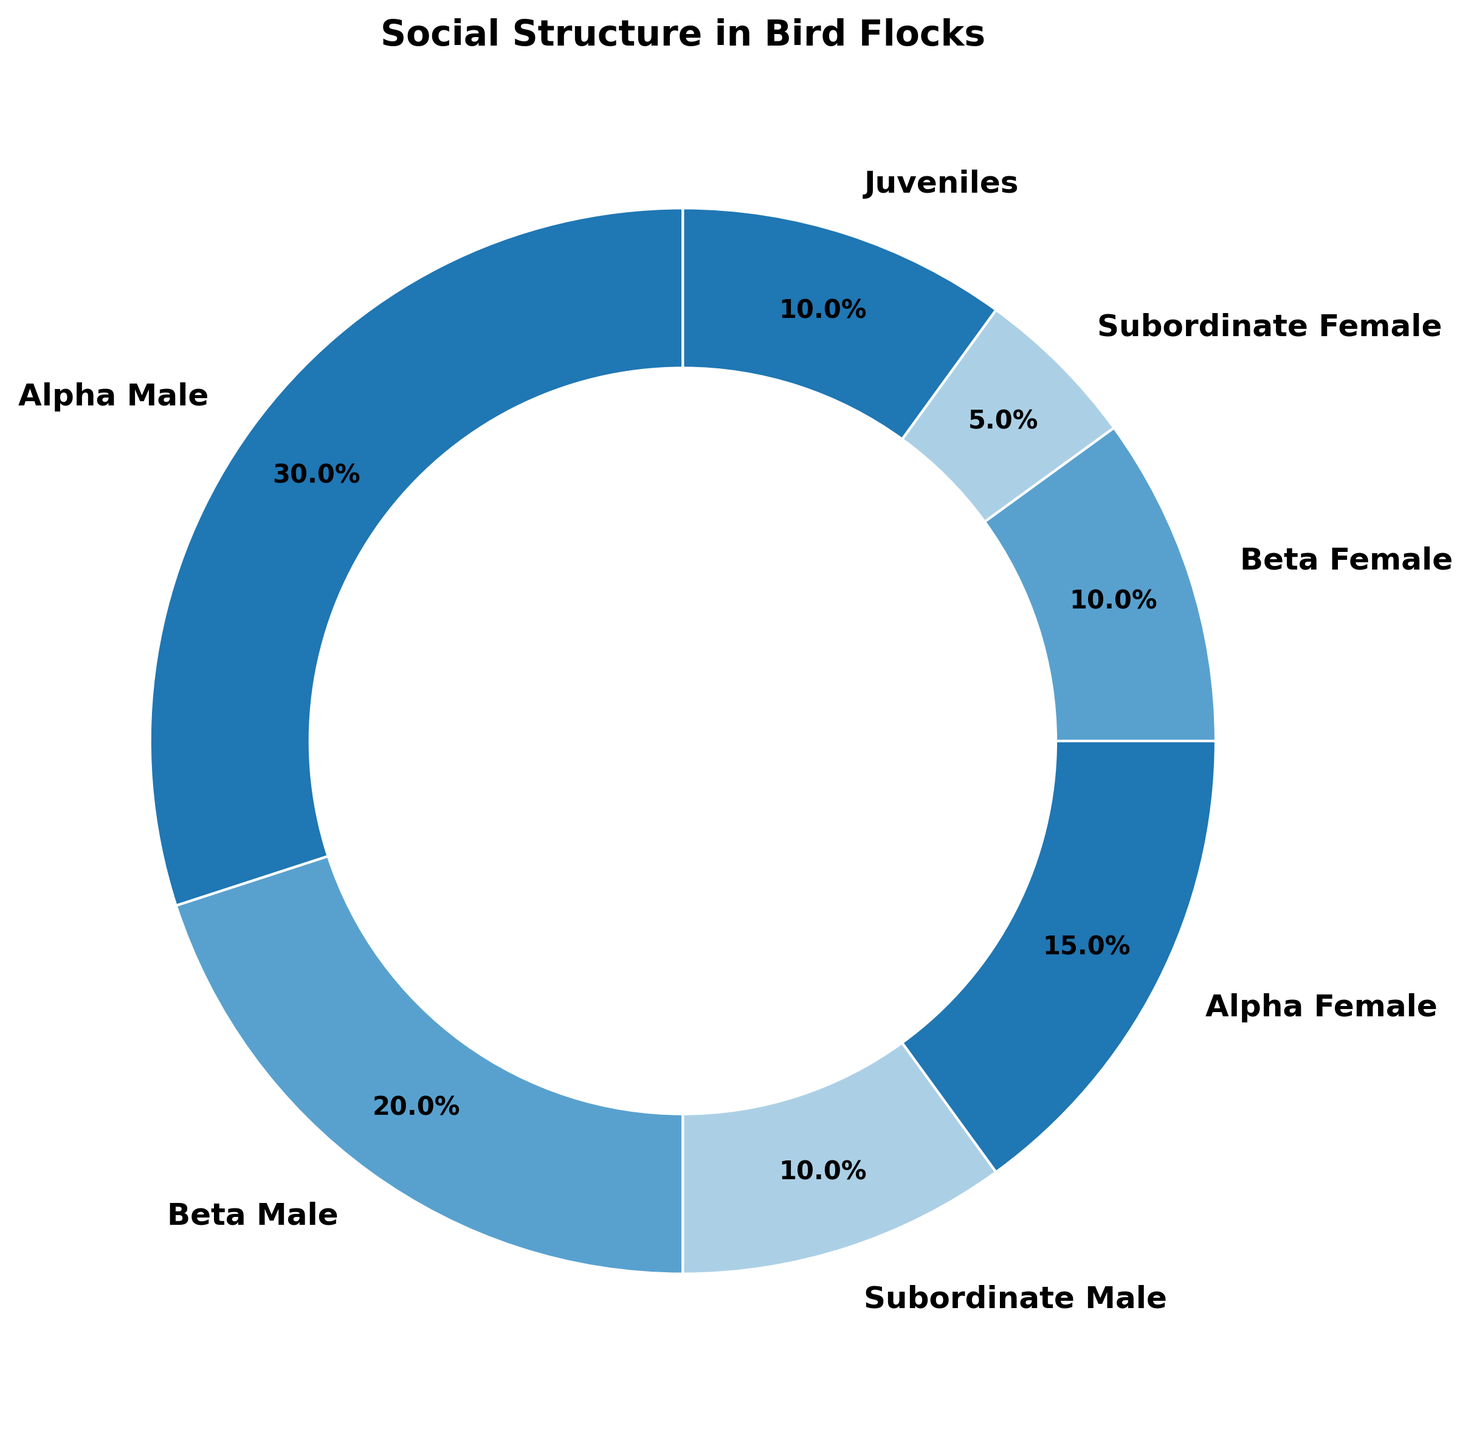What role has the highest percentage in the bird flocks? Alpha Male is at the top with the largest slice in the ring chart, showing a percentage of 30%.
Answer: Alpha Male Which two roles have the smallest percentages in the bird flocks? By looking at the slices, Subordinate Female has 5%, and two other sections, Subordinate Male and Juveniles, each have 10%. Therefore, Subordinate Female and one of these two roles have the smallest percentages, but the absolute smallest are Subordinate Female and tie between Subordinate Male and Juveniles.
Answer: Subordinate Female, Subordinate Male and Juveniles (tie) How much higher is the percentage of Alpha Males compared to Beta Males? Alpha Male has 30%, Beta Male has 20%. The difference is calculated as 30% - 20% = 10%.
Answer: 10% What is the combined percentage representation of all males (Alpha, Beta, Subordinate)? The percentages are 30% (Alpha Male), 20% (Beta Male), and 10% (Subordinate Male). Summing these gives 30 + 20 + 10 = 60%.
Answer: 60% Which roles have an equal percentage, and what is that percentage? The Beta Female and Juveniles sections are of equal size, both with 10%. This is evident by the labels in the ring chart.
Answer: Beta Female, Juveniles; 10% Calculate the total percentage of Alpha and Beta roles together for both sexes. Alpha Male (30%) + Beta Male (20%) + Alpha Female (15%) + Beta Female (10%) = 30 + 20 + 15 + 10 = 75%.
Answer: 75% How does the percentage of Subordinate Female compare with Subordinate Male? Subordinate Female has 5%, and Subordinate Male has 10%. Subordinate Male's percentage is double that of Subordinate Female.
Answer: Subordinate Male is double What roles together represent a quarter (25%) of the bird flocks? Subordinate Male (10%) + Beta Female (10%) + Subordinate Female (5%) sum up to 10 + 10 + 5 = 25%.
Answer: Subordinate Male, Beta Female, Subordinate Female 